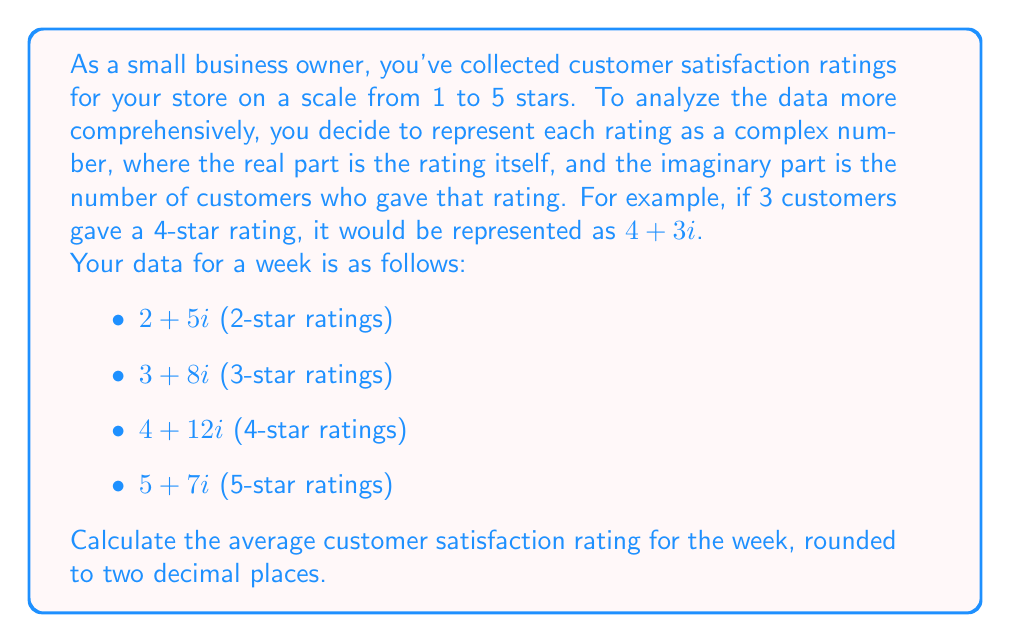Teach me how to tackle this problem. To solve this problem, we'll follow these steps:

1) First, let's calculate the total number of customers:
   $5 + 8 + 12 + 7 = 32$ customers

2) Now, we need to calculate the sum of all ratings. For this, we'll multiply each rating by the number of customers who gave that rating:
   $2 \cdot 5 + 3 \cdot 8 + 4 \cdot 12 + 5 \cdot 7 = 10 + 24 + 48 + 35 = 117$

3) The average rating is the sum of all ratings divided by the total number of customers:
   $$\text{Average} = \frac{117}{32} = 3.65625$$

4) Rounding to two decimal places:
   $3.65625 \approx 3.66$

This method effectively uses the complex number representation to store both the rating and the frequency of that rating in a single number, allowing for efficient data representation and analysis.
Answer: $3.66$ 